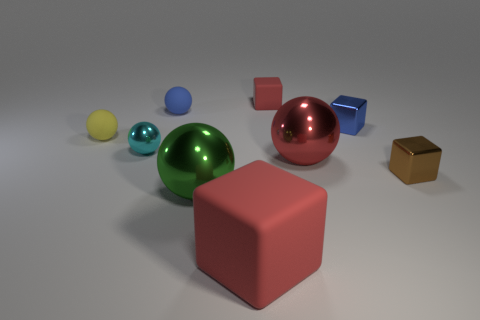What shape is the cyan object that is the same size as the yellow sphere?
Provide a short and direct response. Sphere. There is a blue metal object; are there any metallic things behind it?
Your answer should be very brief. No. Do the blue matte object and the green ball have the same size?
Provide a short and direct response. No. What shape is the tiny metallic thing that is behind the tiny cyan object?
Keep it short and to the point. Cube. Are there any red rubber things of the same size as the blue rubber thing?
Your answer should be compact. Yes. What material is the red object that is the same size as the brown block?
Offer a terse response. Rubber. How big is the matte cube behind the big matte cube?
Give a very brief answer. Small. The brown cube has what size?
Ensure brevity in your answer.  Small. There is a cyan object; does it have the same size as the red block on the right side of the large matte thing?
Provide a succinct answer. Yes. There is a tiny metallic block to the left of the small metal thing right of the blue block; what color is it?
Your answer should be compact. Blue. 